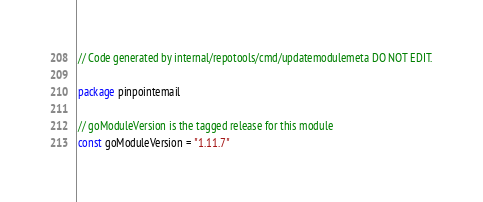Convert code to text. <code><loc_0><loc_0><loc_500><loc_500><_Go_>// Code generated by internal/repotools/cmd/updatemodulemeta DO NOT EDIT.

package pinpointemail

// goModuleVersion is the tagged release for this module
const goModuleVersion = "1.11.7"
</code> 